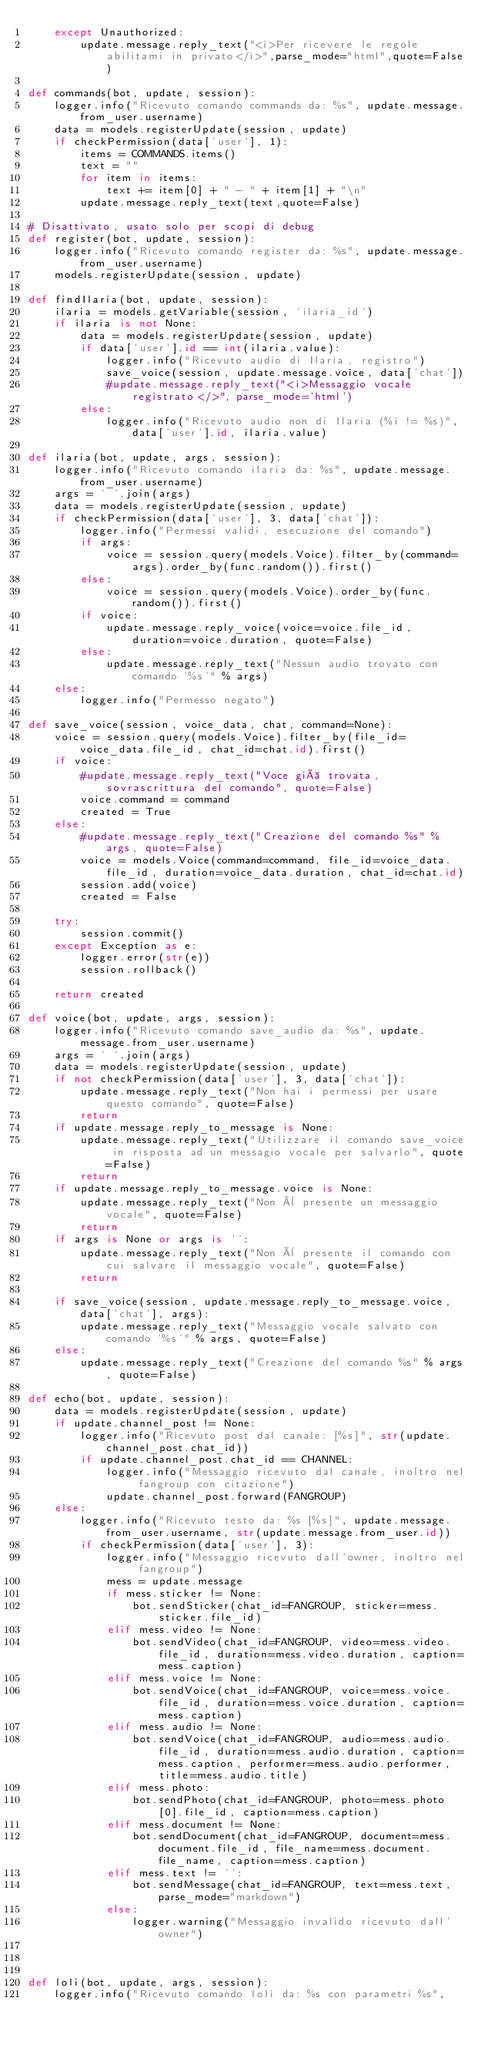Convert code to text. <code><loc_0><loc_0><loc_500><loc_500><_Python_>    except Unauthorized:
        update.message.reply_text("<i>Per ricevere le regole abilitami in privato</i>",parse_mode="html",quote=False)

def commands(bot, update, session):
    logger.info("Ricevuto comando commands da: %s", update.message.from_user.username)
    data = models.registerUpdate(session, update)
    if checkPermission(data['user'], 1):
        items = COMMANDS.items()
        text = ""
        for item in items:
            text += item[0] + " - " + item[1] + "\n"
        update.message.reply_text(text,quote=False)

# Disattivato, usato solo per scopi di debug
def register(bot, update, session):
    logger.info("Ricevuto comando register da: %s", update.message.from_user.username)
    models.registerUpdate(session, update)

def findIlaria(bot, update, session):
    ilaria = models.getVariable(session, 'ilaria_id')
    if ilaria is not None:
        data = models.registerUpdate(session, update)
        if data['user'].id == int(ilaria.value):
            logger.info("Ricevuto audio di Ilaria, registro")
            save_voice(session, update.message.voice, data['chat'])
            #update.message.reply_text("<i>Messaggio vocale registrato</>", parse_mode='html')
        else:
            logger.info("Ricevuto audio non di Ilaria (%i != %s)", data['user'].id, ilaria.value)

def ilaria(bot, update, args, session):
    logger.info("Ricevuto comando ilaria da: %s", update.message.from_user.username)
    args = ' '.join(args)
    data = models.registerUpdate(session, update)
    if checkPermission(data['user'], 3, data['chat']):
        logger.info("Permessi validi, esecuzione del comando")
        if args:
            voice = session.query(models.Voice).filter_by(command=args).order_by(func.random()).first()
        else:
            voice = session.query(models.Voice).order_by(func.random()).first()
        if voice:
            update.message.reply_voice(voice=voice.file_id, duration=voice.duration, quote=False)
        else:
            update.message.reply_text("Nessun audio trovato con comando '%s'" % args)
    else:
        logger.info("Permesso negato")

def save_voice(session, voice_data, chat, command=None):
    voice = session.query(models.Voice).filter_by(file_id=voice_data.file_id, chat_id=chat.id).first()
    if voice:
        #update.message.reply_text("Voce già trovata, sovrascrittura del comando", quote=False)
        voice.command = command
        created = True
    else:
        #update.message.reply_text("Creazione del comando %s" % args, quote=False)
        voice = models.Voice(command=command, file_id=voice_data.file_id, duration=voice_data.duration, chat_id=chat.id)
        session.add(voice)
        created = False

    try:
        session.commit()
    except Exception as e:
        logger.error(str(e))
        session.rollback()

    return created

def voice(bot, update, args, session):
    logger.info("Ricevuto comando save_audio da: %s", update.message.from_user.username)
    args = ' '.join(args)
    data = models.registerUpdate(session, update)
    if not checkPermission(data['user'], 3, data['chat']):
        update.message.reply_text("Non hai i permessi per usare questo comando", quote=False)
        return
    if update.message.reply_to_message is None:
        update.message.reply_text("Utilizzare il comando save_voice in risposta ad un messagio vocale per salvarlo", quote=False)
        return
    if update.message.reply_to_message.voice is None:
        update.message.reply_text("Non è presente un messaggio vocale", quote=False)
        return
    if args is None or args is '':
        update.message.reply_text("Non è presente il comando con cui salvare il messaggio vocale", quote=False)
        return

    if save_voice(session, update.message.reply_to_message.voice, data['chat'], args):
        update.message.reply_text("Messaggio vocale salvato con comando '%s'" % args, quote=False)
    else:
        update.message.reply_text("Creazione del comando %s" % args, quote=False)

def echo(bot, update, session):
    data = models.registerUpdate(session, update)
    if update.channel_post != None:
        logger.info("Ricevuto post dal canale: [%s]", str(update.channel_post.chat_id))
        if update.channel_post.chat_id == CHANNEL:
            logger.info("Messaggio ricevuto dal canale, inoltro nel fangroup con citazione")
            update.channel_post.forward(FANGROUP)
    else:
        logger.info("Ricevuto testo da: %s [%s]", update.message.from_user.username, str(update.message.from_user.id))
        if checkPermission(data['user'], 3):
            logger.info("Messaggio ricevuto dall'owner, inoltro nel fangroup")
            mess = update.message
            if mess.sticker != None:
                bot.sendSticker(chat_id=FANGROUP, sticker=mess.sticker.file_id)
            elif mess.video != None:
                bot.sendVideo(chat_id=FANGROUP, video=mess.video.file_id, duration=mess.video.duration, caption=mess.caption)
            elif mess.voice != None:
                bot.sendVoice(chat_id=FANGROUP, voice=mess.voice.file_id, duration=mess.voice.duration, caption=mess.caption)
            elif mess.audio != None:
                bot.sendVoice(chat_id=FANGROUP, audio=mess.audio.file_id, duration=mess.audio.duration, caption=mess.caption, performer=mess.audio.performer, title=mess.audio.title)
            elif mess.photo:
                bot.sendPhoto(chat_id=FANGROUP, photo=mess.photo[0].file_id, caption=mess.caption)
            elif mess.document != None:
                bot.sendDocument(chat_id=FANGROUP, document=mess.document.file_id, file_name=mess.document.file_name, caption=mess.caption)
            elif mess.text != '':
                bot.sendMessage(chat_id=FANGROUP, text=mess.text, parse_mode="markdown")
            else:
                logger.warning("Messaggio invalido ricevuto dall'owner")



def loli(bot, update, args, session):
    logger.info("Ricevuto comando loli da: %s con parametri %s",</code> 